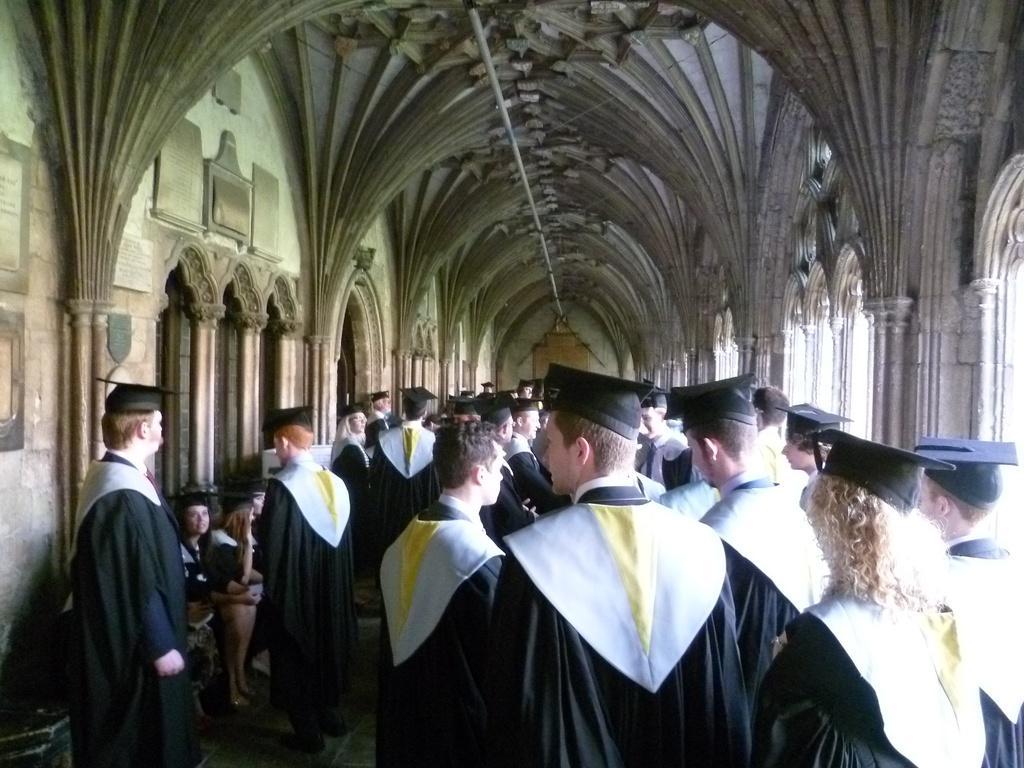Please provide a concise description of this image. In this image we can see there are a few people standing and some are sitting inside the building. 